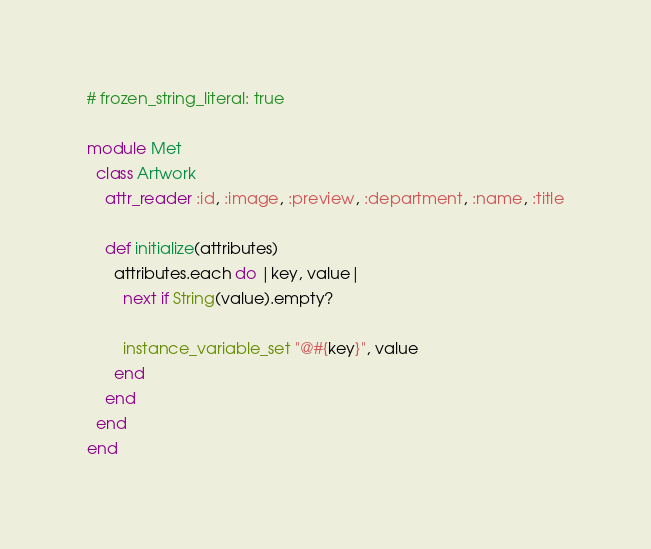Convert code to text. <code><loc_0><loc_0><loc_500><loc_500><_Ruby_># frozen_string_literal: true

module Met
  class Artwork
    attr_reader :id, :image, :preview, :department, :name, :title

    def initialize(attributes)
      attributes.each do |key, value|
        next if String(value).empty?

        instance_variable_set "@#{key}", value
      end
    end
  end
end
</code> 